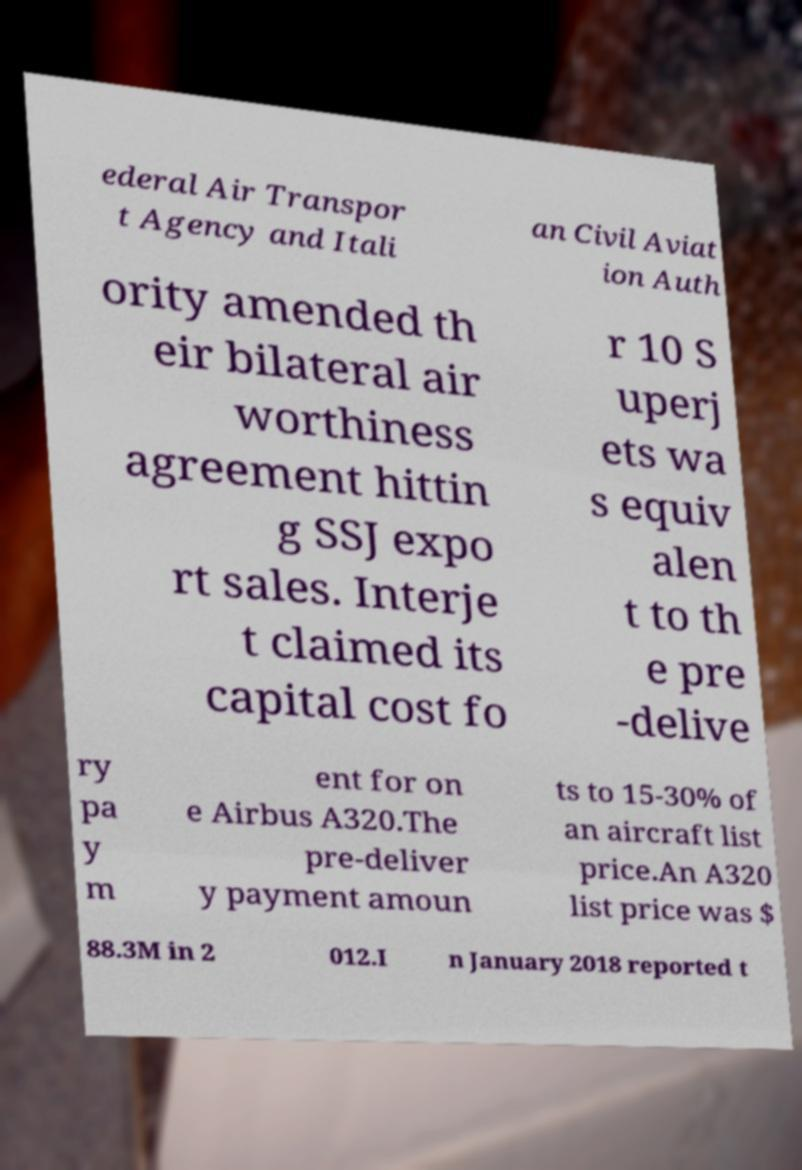Please read and relay the text visible in this image. What does it say? ederal Air Transpor t Agency and Itali an Civil Aviat ion Auth ority amended th eir bilateral air worthiness agreement hittin g SSJ expo rt sales. Interje t claimed its capital cost fo r 10 S uperj ets wa s equiv alen t to th e pre -delive ry pa y m ent for on e Airbus A320.The pre-deliver y payment amoun ts to 15-30% of an aircraft list price.An A320 list price was $ 88.3M in 2 012.I n January 2018 reported t 